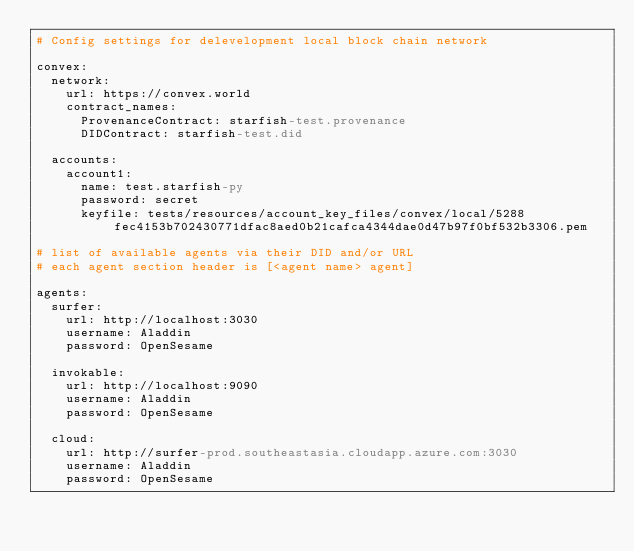Convert code to text. <code><loc_0><loc_0><loc_500><loc_500><_YAML_># Config settings for delevelopment local block chain network

convex:
  network:
    url: https://convex.world
    contract_names:
      ProvenanceContract: starfish-test.provenance
      DIDContract: starfish-test.did

  accounts:
    account1:
      name: test.starfish-py
      password: secret
      keyfile: tests/resources/account_key_files/convex/local/5288fec4153b702430771dfac8aed0b21cafca4344dae0d47b97f0bf532b3306.pem

# list of available agents via their DID and/or URL
# each agent section header is [<agent name> agent]

agents:
  surfer:
    url: http://localhost:3030
    username: Aladdin
    password: OpenSesame

  invokable:
    url: http://localhost:9090
    username: Aladdin
    password: OpenSesame

  cloud:
    url: http://surfer-prod.southeastasia.cloudapp.azure.com:3030
    username: Aladdin
    password: OpenSesame
</code> 